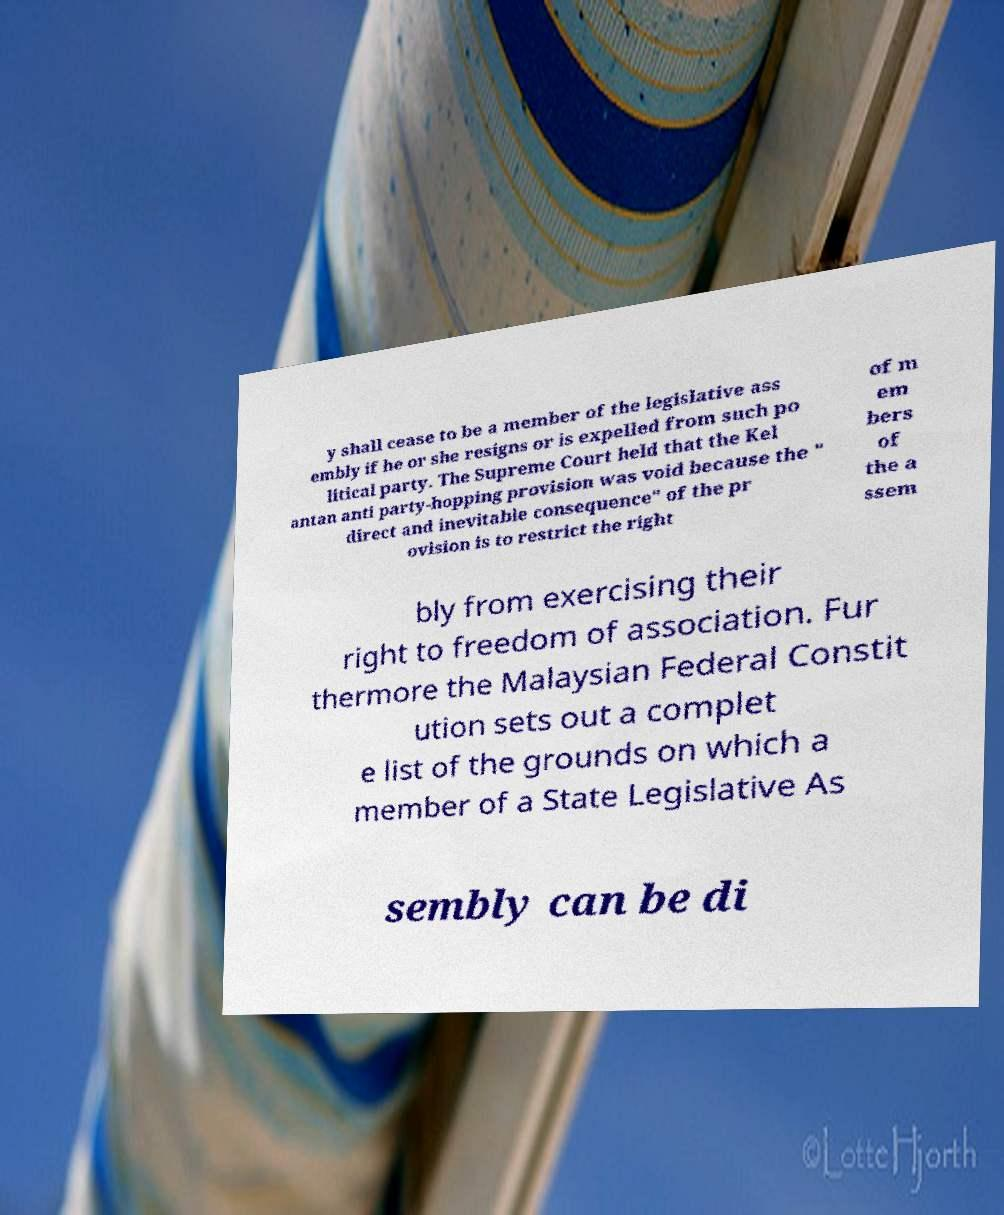Could you assist in decoding the text presented in this image and type it out clearly? y shall cease to be a member of the legislative ass embly if he or she resigns or is expelled from such po litical party. The Supreme Court held that the Kel antan anti party-hopping provision was void because the " direct and inevitable consequence" of the pr ovision is to restrict the right of m em bers of the a ssem bly from exercising their right to freedom of association. Fur thermore the Malaysian Federal Constit ution sets out a complet e list of the grounds on which a member of a State Legislative As sembly can be di 